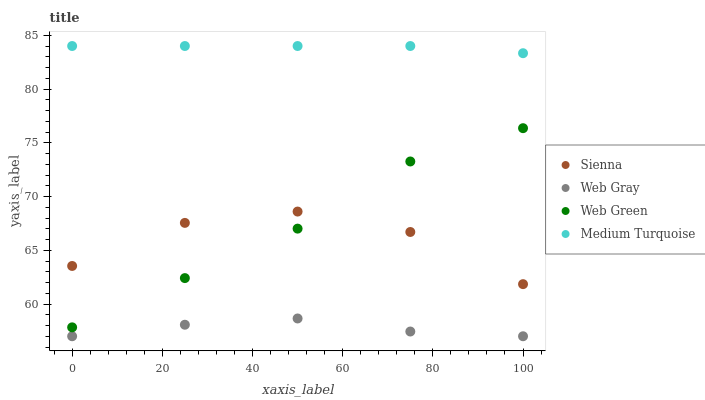Does Web Gray have the minimum area under the curve?
Answer yes or no. Yes. Does Medium Turquoise have the maximum area under the curve?
Answer yes or no. Yes. Does Medium Turquoise have the minimum area under the curve?
Answer yes or no. No. Does Web Gray have the maximum area under the curve?
Answer yes or no. No. Is Medium Turquoise the smoothest?
Answer yes or no. Yes. Is Sienna the roughest?
Answer yes or no. Yes. Is Web Gray the smoothest?
Answer yes or no. No. Is Web Gray the roughest?
Answer yes or no. No. Does Web Gray have the lowest value?
Answer yes or no. Yes. Does Medium Turquoise have the lowest value?
Answer yes or no. No. Does Medium Turquoise have the highest value?
Answer yes or no. Yes. Does Web Gray have the highest value?
Answer yes or no. No. Is Web Green less than Medium Turquoise?
Answer yes or no. Yes. Is Sienna greater than Web Gray?
Answer yes or no. Yes. Does Web Green intersect Sienna?
Answer yes or no. Yes. Is Web Green less than Sienna?
Answer yes or no. No. Is Web Green greater than Sienna?
Answer yes or no. No. Does Web Green intersect Medium Turquoise?
Answer yes or no. No. 